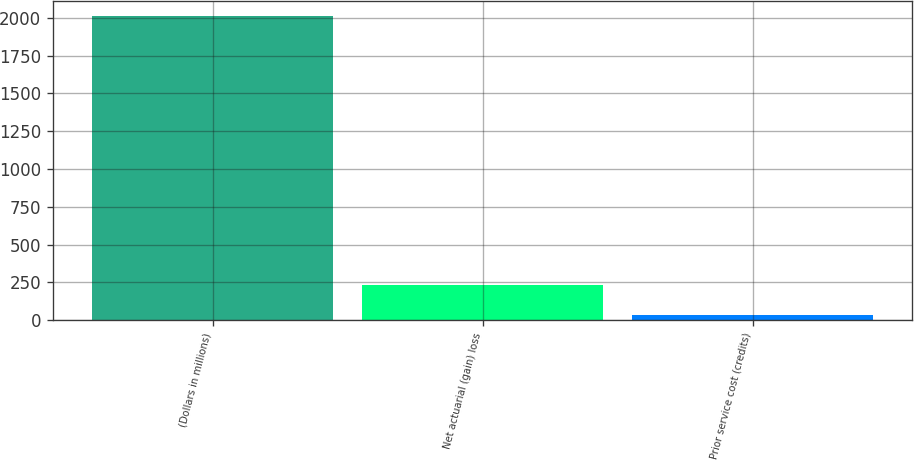<chart> <loc_0><loc_0><loc_500><loc_500><bar_chart><fcel>(Dollars in millions)<fcel>Net actuarial (gain) loss<fcel>Prior service cost (credits)<nl><fcel>2011<fcel>230.8<fcel>33<nl></chart> 